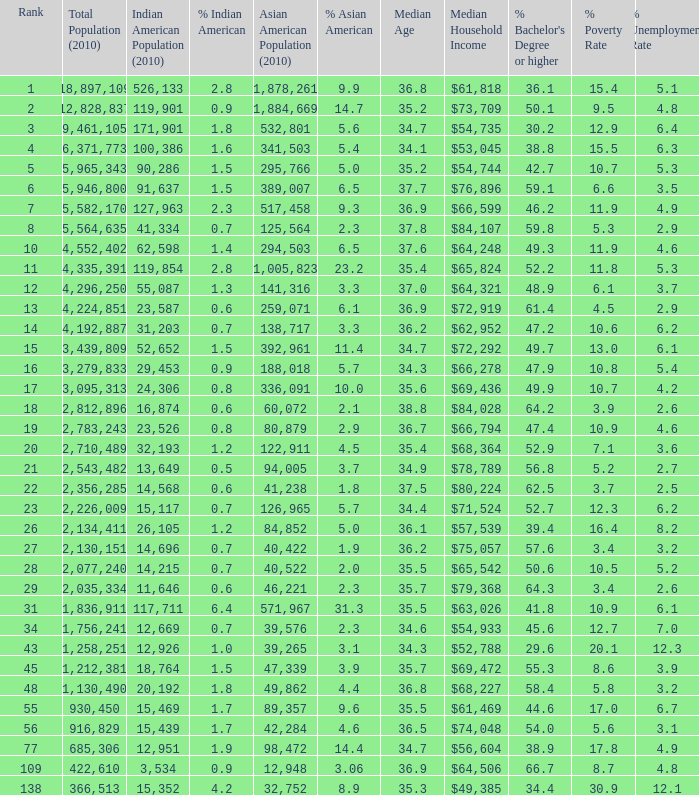Would you be able to parse every entry in this table? {'header': ['Rank', 'Total Population (2010)', 'Indian American Population (2010)', '% Indian American', 'Asian American Population (2010)', '% Asian American', 'Median Age', 'Median Household Income', "% Bachelor's Degree or higher", '% Poverty Rate', '% Unemployment Rate'], 'rows': [['1', '18,897,109', '526,133', '2.8', '1,878,261', '9.9', '36.8', '$61,818', '36.1', '15.4', '5.1'], ['2', '12,828,837', '119,901', '0.9', '1,884,669', '14.7', '35.2', '$73,709', '50.1', '9.5', '4.8'], ['3', '9,461,105', '171,901', '1.8', '532,801', '5.6', '34.7', '$54,735', '30.2', '12.9', '6.4'], ['4', '6,371,773', '100,386', '1.6', '341,503', '5.4', '34.1', '$53,045', '38.8', '15.5', '6.3'], ['5', '5,965,343', '90,286', '1.5', '295,766', '5.0', '35.2', '$54,744', '42.7', '10.7', '5.3'], ['6', '5,946,800', '91,637', '1.5', '389,007', '6.5', '37.7', '$76,896', '59.1', '6.6', '3.5'], ['7', '5,582,170', '127,963', '2.3', '517,458', '9.3', '36.9', '$66,599', '46.2', '11.9', '4.9'], ['8', '5,564,635', '41,334', '0.7', '125,564', '2.3', '37.8', '$84,107', '59.8', '5.3', '2.9'], ['10', '4,552,402', '62,598', '1.4', '294,503', '6.5', '37.6', '$64,248', '49.3', '11.9', '4.6'], ['11', '4,335,391', '119,854', '2.8', '1,005,823', '23.2', '35.4', '$65,824', '52.2', '11.8', '5.3'], ['12', '4,296,250', '55,087', '1.3', '141,316', '3.3', '37.0', '$64,321', '48.9', '6.1', '3.7'], ['13', '4,224,851', '23,587', '0.6', '259,071', '6.1', '36.9', '$72,919', '61.4', '4.5', '2.9'], ['14', '4,192,887', '31,203', '0.7', '138,717', '3.3', '36.2', '$62,952', '47.2', '10.6', '6.2'], ['15', '3,439,809', '52,652', '1.5', '392,961', '11.4', '34.7', '$72,292', '49.7', '13.0', '6.1'], ['16', '3,279,833', '29,453', '0.9', '188,018', '5.7', '34.3', '$66,278', '47.9', '10.8', '5.4'], ['17', '3,095,313', '24,306', '0.8', '336,091', '10.0', '35.6', '$69,436', '49.9', '10.7', '4.2'], ['18', '2,812,896', '16,874', '0.6', '60,072', '2.1', '38.8', '$84,028', '64.2', '3.9', '2.6'], ['19', '2,783,243', '23,526', '0.8', '80,879', '2.9', '36.7', '$66,794', '47.4', '10.9', '4.6'], ['20', '2,710,489', '32,193', '1.2', '122,911', '4.5', '35.4', '$68,364', '52.9', '7.1', '3.6'], ['21', '2,543,482', '13,649', '0.5', '94,005', '3.7', '34.9', '$78,789', '56.8', '5.2', '2.7'], ['22', '2,356,285', '14,568', '0.6', '41,238', '1.8', '37.5', '$80,224', '62.5', '3.7', '2.5'], ['23', '2,226,009', '15,117', '0.7', '126,965', '5.7', '34.4', '$71,524', '52.7', '12.3', '6.2'], ['26', '2,134,411', '26,105', '1.2', '84,852', '5.0', '36.1', '$57,539', '39.4', '16.4', '8.2'], ['27', '2,130,151', '14,696', '0.7', '40,422', '1.9', '36.2', '$75,057', '57.6', '3.4', '3.2'], ['28', '2,077,240', '14,215', '0.7', '40,522', '2.0', '35.5', '$65,542', '50.6', '10.5', '5.2'], ['29', '2,035,334', '11,646', '0.6', '46,221', '2.3', '35.7', '$79,368', '64.3', '3.4', '2.6'], ['31', '1,836,911', '117,711', '6.4', '571,967', '31.3', '35.5', '$63,026', '41.8', '10.9', '6.1'], ['34', '1,756,241', '12,669', '0.7', '39,576', '2.3', '34.6', '$54,933', '45.6', '12.7', '7.0'], ['43', '1,258,251', '12,926', '1.0', '39,265', '3.1', '34.3', '$52,788', '29.6', '20.1', '12.3'], ['45', '1,212,381', '18,764', '1.5', '47,339', '3.9', '35.7', '$69,472', '55.3', '8.6', '3.9'], ['48', '1,130,490', '20,192', '1.8', '49,862', '4.4', '36.8', '$68,227', '58.4', '5.8', '3.2'], ['55', '930,450', '15,469', '1.7', '89,357', '9.6', '35.5', '$61,469', '44.6', '17.0', '6.7'], ['56', '916,829', '15,439', '1.7', '42,284', '4.6', '36.5', '$74,048', '54.0', '5.6', '3.1'], ['77', '685,306', '12,951', '1.9', '98,472', '14.4', '34.7', '$56,604', '38.9', '17.8', '4.9'], ['109', '422,610', '3,534', '0.9', '12,948', '3.06', '36.9', '$64,506', '66.7', '8.7', '4.8'], ['138', '366,513', '15,352', '4.2', '32,752', '8.9', '35.3', '$49,385', '34.4', '30.9', '12.1']]} What's the total population when the Asian American population is less than 60,072, the Indian American population is more than 14,696 and is 4.2% Indian American? 366513.0. 